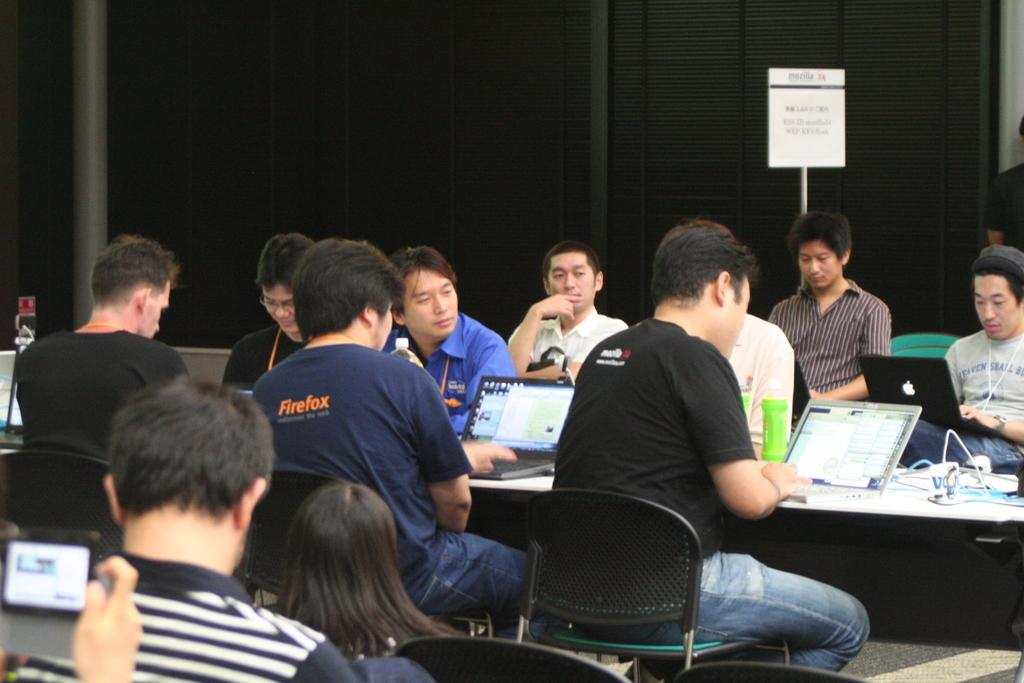What type of location is shown in the image? The image depicts a meeting hall. How are the people arranged in the hall? There are many people sitting on chairs in the hall. What is located in front of the chairs? There is a table in front of the chairs. What electronic devices are on the table? Laptops are present on the table. What other object can be seen on the table? There is a bottle on the table. What is visible in the background of the image? There is a wall in the background of the image. How many apples are on the table in the image? There are no apples present on the table in the image. What type of wrist support is being used by the people sitting on the chairs? There is no wrist support visible in the image; the people are simply sitting on chairs. 